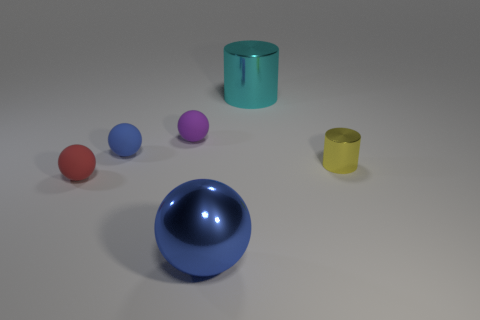Does the small yellow object have the same shape as the red matte object?
Give a very brief answer. No. How many other things are there of the same size as the purple thing?
Your answer should be very brief. 3. Is there any other thing of the same color as the large ball?
Your response must be concise. Yes. Are there an equal number of matte balls on the right side of the small blue ball and blue spheres that are behind the large cyan metallic thing?
Your answer should be compact. No. Are there more yellow objects that are left of the tiny red rubber object than small cyan metal balls?
Offer a terse response. No. How many things are either tiny objects left of the big cyan cylinder or large blue metallic spheres?
Make the answer very short. 4. How many small purple spheres are the same material as the red ball?
Keep it short and to the point. 1. What is the shape of the tiny object that is the same color as the shiny ball?
Your response must be concise. Sphere. Are there any other tiny rubber things that have the same shape as the purple rubber thing?
Make the answer very short. Yes. There is a purple thing that is the same size as the yellow metal cylinder; what shape is it?
Keep it short and to the point. Sphere. 